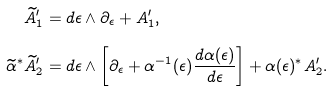<formula> <loc_0><loc_0><loc_500><loc_500>\widetilde { A } ^ { \prime } _ { 1 } & = d \epsilon \wedge \partial _ { \epsilon } + A ^ { \prime } _ { 1 } , \\ \widetilde { \alpha } ^ { * } \widetilde { A } ^ { \prime } _ { 2 } & = d \epsilon \wedge \left [ \partial _ { \epsilon } + \alpha ^ { - 1 } ( \epsilon ) \frac { d \alpha ( \epsilon ) } { d \epsilon } \right ] + \alpha ( \epsilon ) ^ { * } A ^ { \prime } _ { 2 } .</formula> 